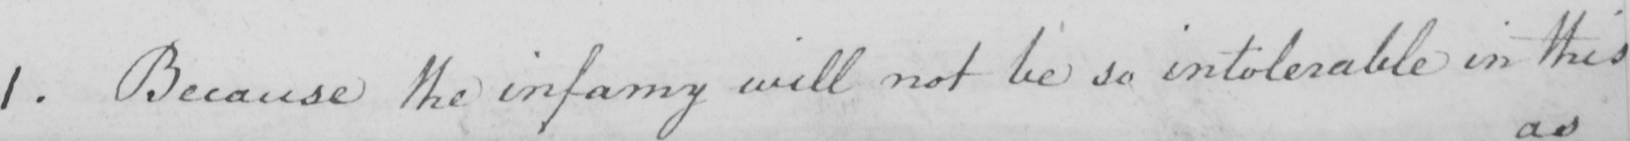What does this handwritten line say? 1 . Because the infamy will not be so intolerable in this 